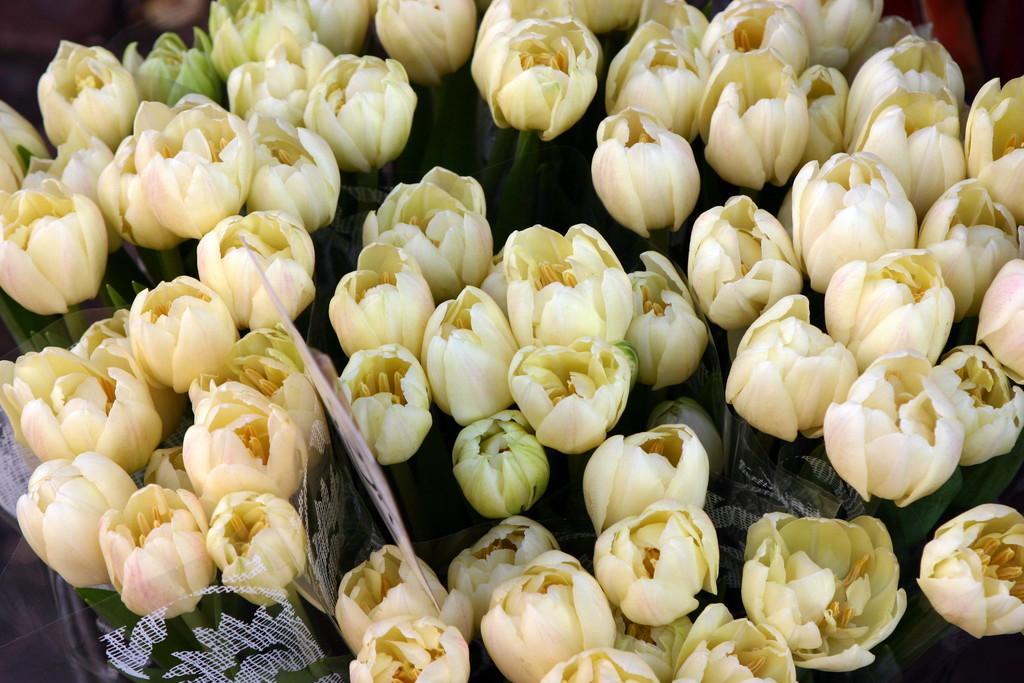Describe this image in one or two sentences. In the foreground of this image, there are lotus flowers bouquets and a name board. 